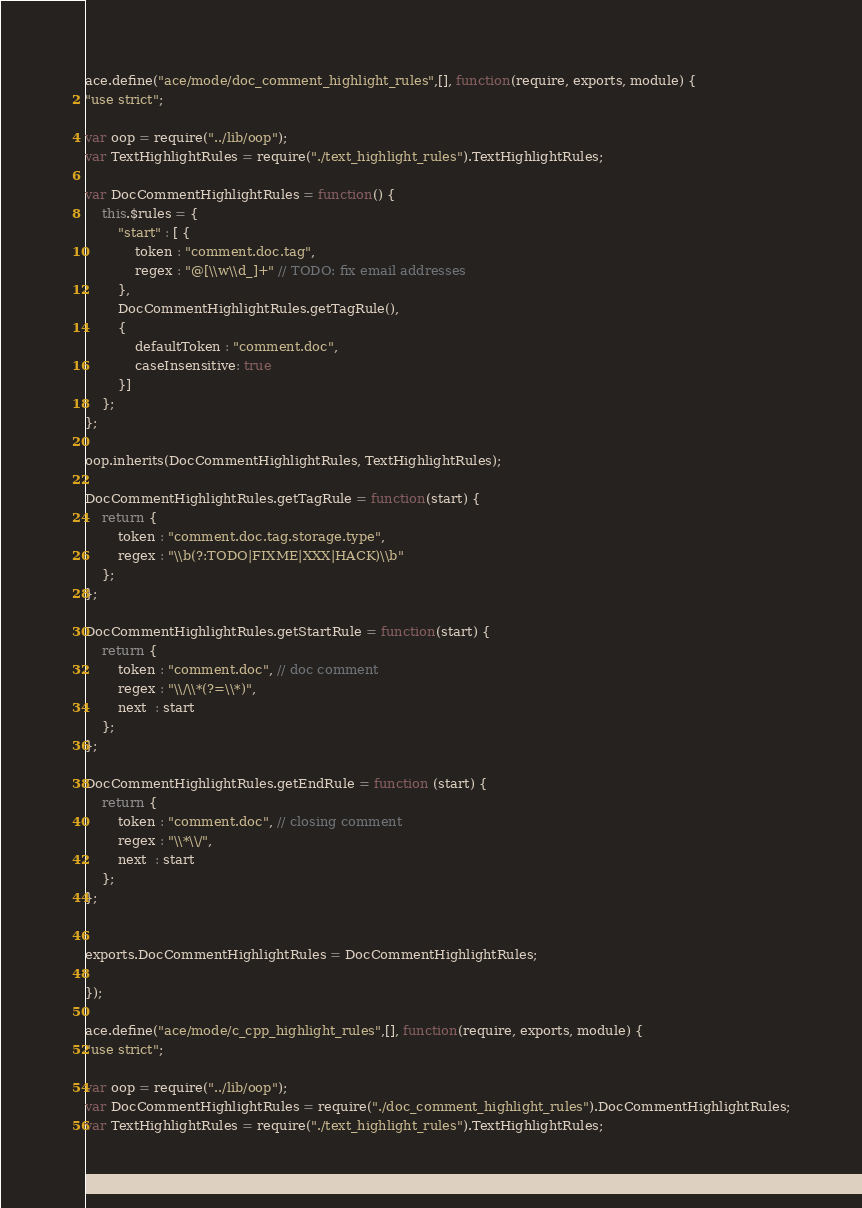Convert code to text. <code><loc_0><loc_0><loc_500><loc_500><_JavaScript_>ace.define("ace/mode/doc_comment_highlight_rules",[], function(require, exports, module) {
"use strict";

var oop = require("../lib/oop");
var TextHighlightRules = require("./text_highlight_rules").TextHighlightRules;

var DocCommentHighlightRules = function() {
    this.$rules = {
        "start" : [ {
            token : "comment.doc.tag",
            regex : "@[\\w\\d_]+" // TODO: fix email addresses
        }, 
        DocCommentHighlightRules.getTagRule(),
        {
            defaultToken : "comment.doc",
            caseInsensitive: true
        }]
    };
};

oop.inherits(DocCommentHighlightRules, TextHighlightRules);

DocCommentHighlightRules.getTagRule = function(start) {
    return {
        token : "comment.doc.tag.storage.type",
        regex : "\\b(?:TODO|FIXME|XXX|HACK)\\b"
    };
};

DocCommentHighlightRules.getStartRule = function(start) {
    return {
        token : "comment.doc", // doc comment
        regex : "\\/\\*(?=\\*)",
        next  : start
    };
};

DocCommentHighlightRules.getEndRule = function (start) {
    return {
        token : "comment.doc", // closing comment
        regex : "\\*\\/",
        next  : start
    };
};


exports.DocCommentHighlightRules = DocCommentHighlightRules;

});

ace.define("ace/mode/c_cpp_highlight_rules",[], function(require, exports, module) {
"use strict";

var oop = require("../lib/oop");
var DocCommentHighlightRules = require("./doc_comment_highlight_rules").DocCommentHighlightRules;
var TextHighlightRules = require("./text_highlight_rules").TextHighlightRules;</code> 